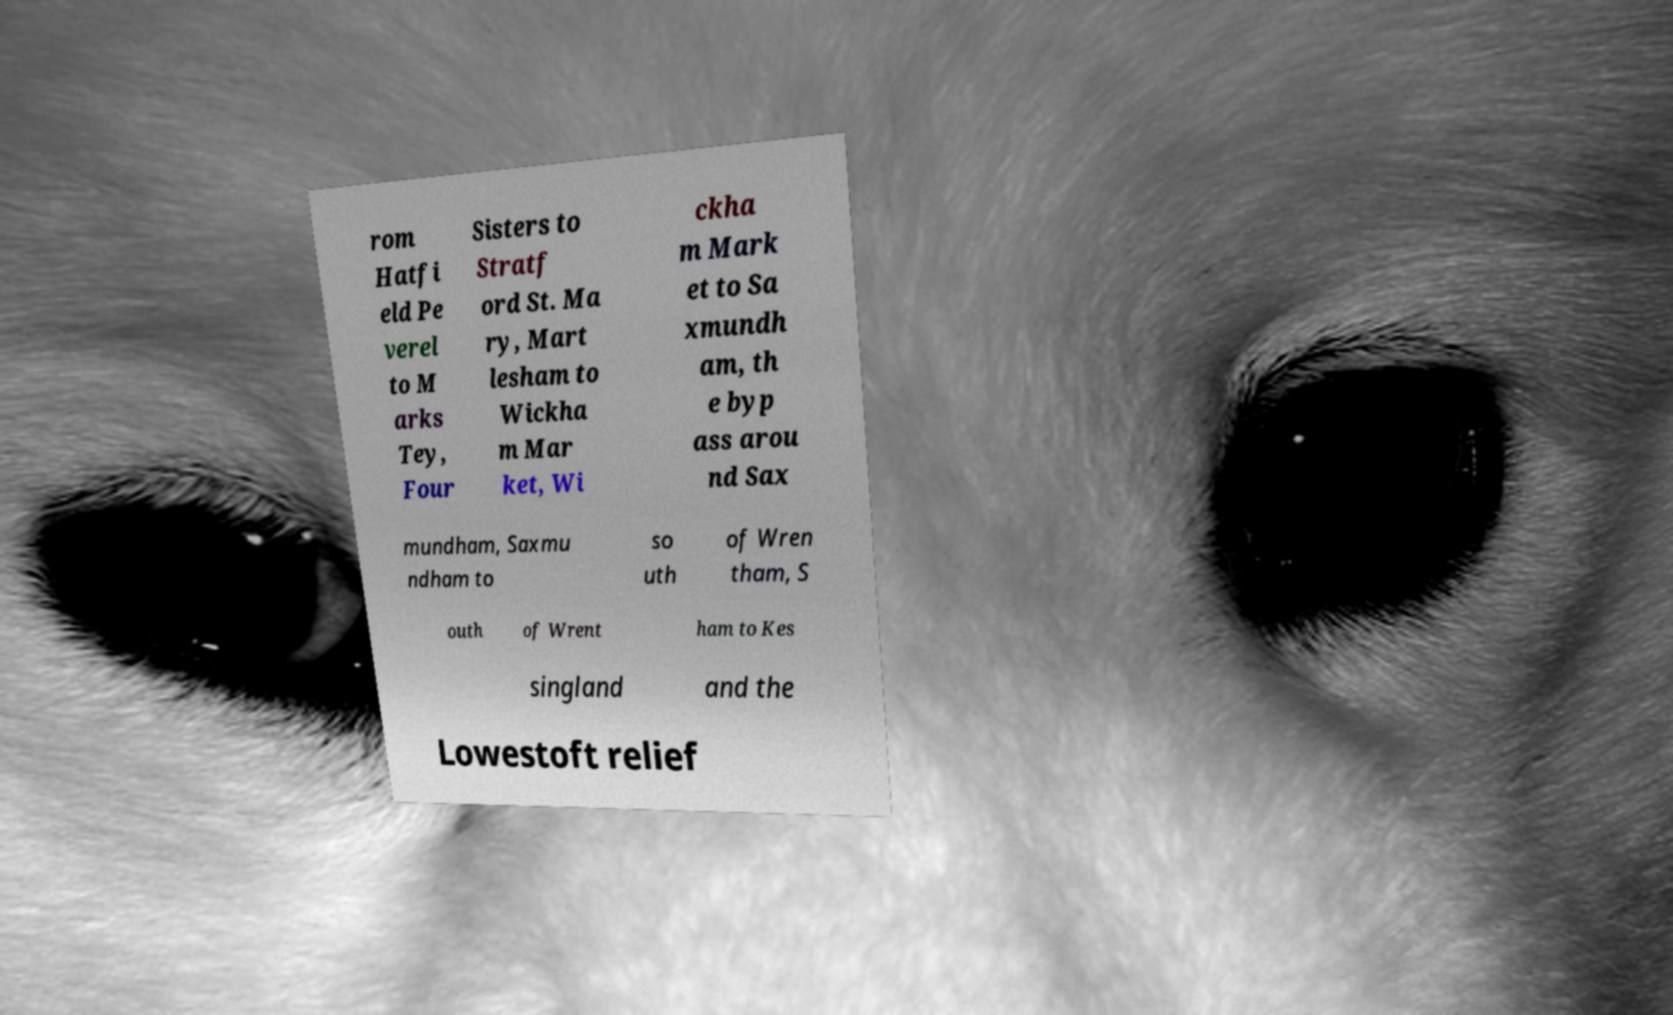What messages or text are displayed in this image? I need them in a readable, typed format. rom Hatfi eld Pe verel to M arks Tey, Four Sisters to Stratf ord St. Ma ry, Mart lesham to Wickha m Mar ket, Wi ckha m Mark et to Sa xmundh am, th e byp ass arou nd Sax mundham, Saxmu ndham to so uth of Wren tham, S outh of Wrent ham to Kes singland and the Lowestoft relief 